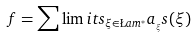Convert formula to latex. <formula><loc_0><loc_0><loc_500><loc_500>f = \sum \lim i t s _ { \xi \in \L a m ^ { * } } a _ { _ { \xi } } s ( \xi )</formula> 